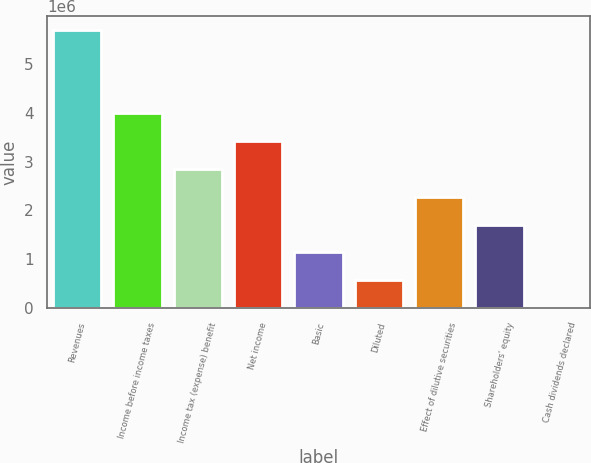Convert chart to OTSL. <chart><loc_0><loc_0><loc_500><loc_500><bar_chart><fcel>Revenues<fcel>Income before income taxes<fcel>Income tax (expense) benefit<fcel>Net income<fcel>Basic<fcel>Diluted<fcel>Effect of dilutive securities<fcel>Shareholders' equity<fcel>Cash dividends declared<nl><fcel>5.70034e+06<fcel>3.99024e+06<fcel>2.85017e+06<fcel>3.4202e+06<fcel>1.14007e+06<fcel>570034<fcel>2.28014e+06<fcel>1.7101e+06<fcel>0.23<nl></chart> 